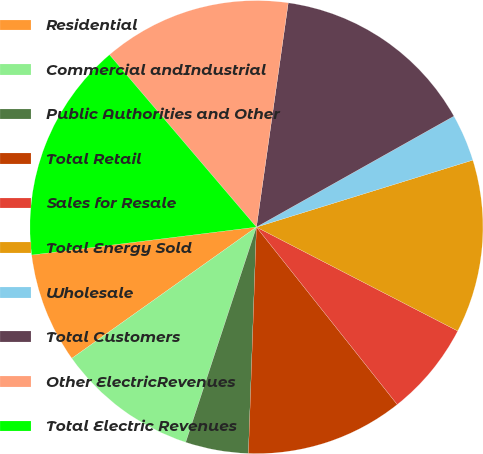Convert chart to OTSL. <chart><loc_0><loc_0><loc_500><loc_500><pie_chart><fcel>Residential<fcel>Commercial andIndustrial<fcel>Public Authorities and Other<fcel>Total Retail<fcel>Sales for Resale<fcel>Total Energy Sold<fcel>Wholesale<fcel>Total Customers<fcel>Other ElectricRevenues<fcel>Total Electric Revenues<nl><fcel>7.87%<fcel>10.11%<fcel>4.49%<fcel>11.24%<fcel>6.74%<fcel>12.36%<fcel>3.37%<fcel>14.61%<fcel>13.48%<fcel>15.73%<nl></chart> 